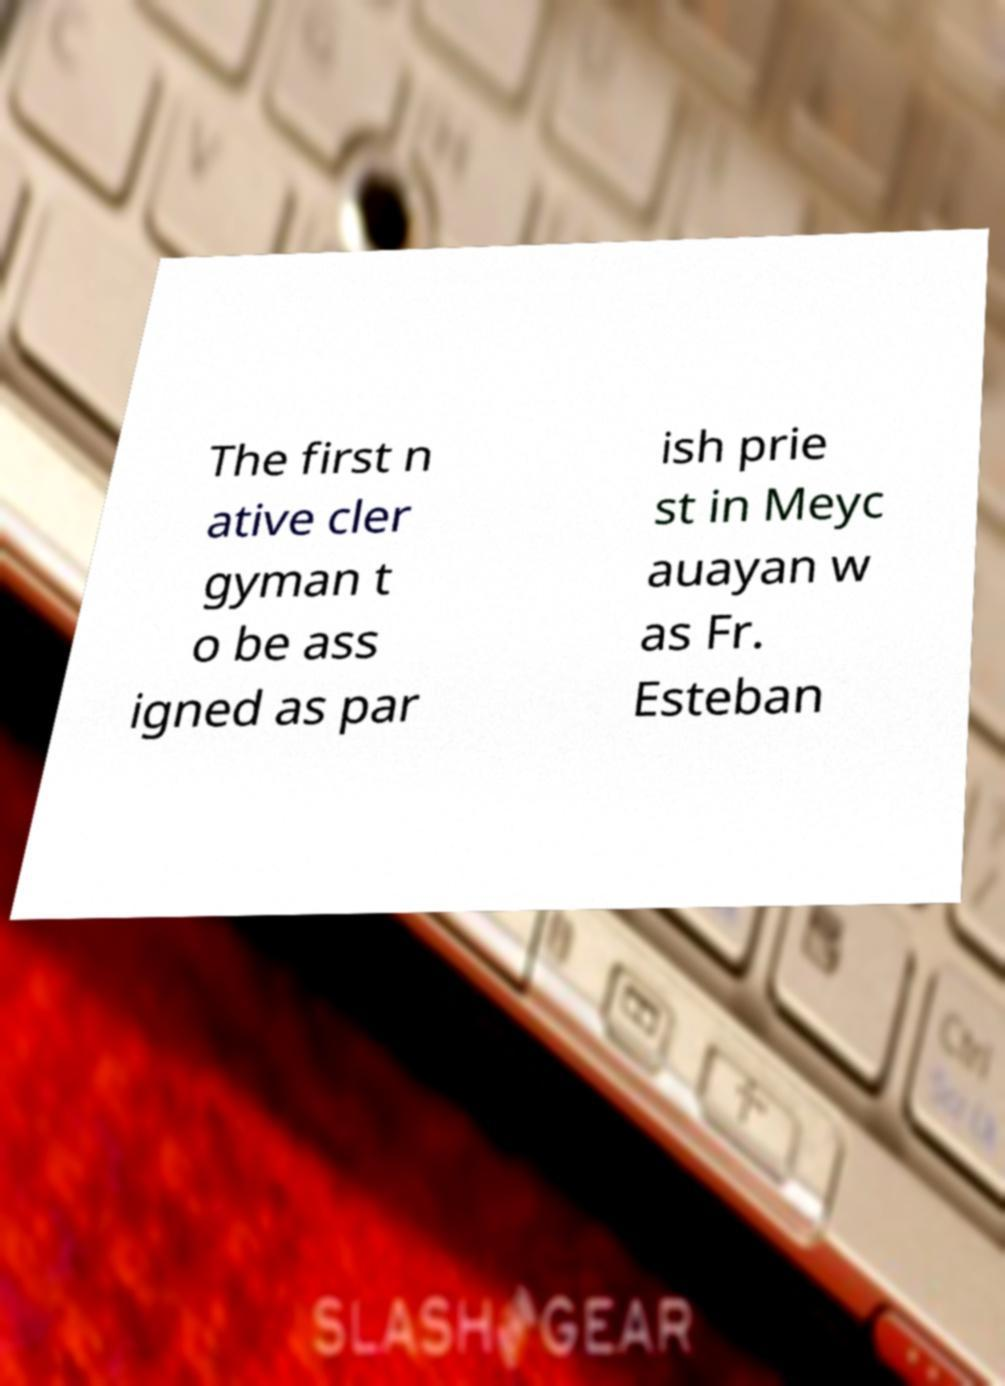I need the written content from this picture converted into text. Can you do that? The first n ative cler gyman t o be ass igned as par ish prie st in Meyc auayan w as Fr. Esteban 